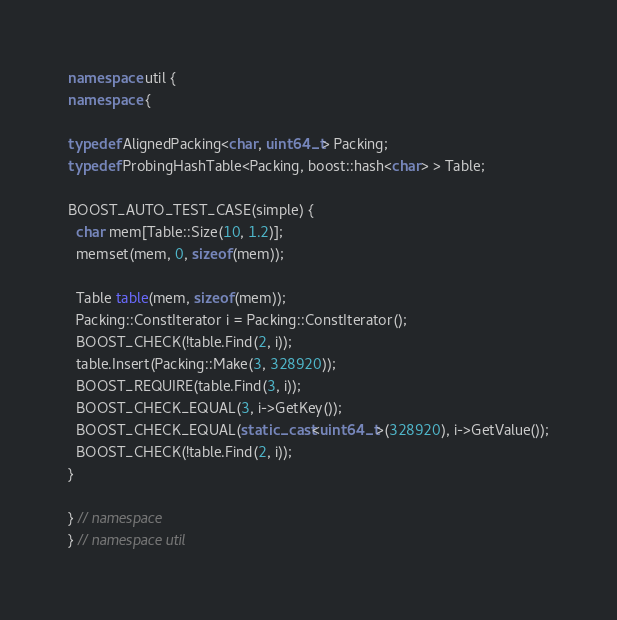<code> <loc_0><loc_0><loc_500><loc_500><_C++_>
namespace util {
namespace {

typedef AlignedPacking<char, uint64_t> Packing;
typedef ProbingHashTable<Packing, boost::hash<char> > Table;

BOOST_AUTO_TEST_CASE(simple) {
  char mem[Table::Size(10, 1.2)];
  memset(mem, 0, sizeof(mem));

  Table table(mem, sizeof(mem));
  Packing::ConstIterator i = Packing::ConstIterator();
  BOOST_CHECK(!table.Find(2, i));
  table.Insert(Packing::Make(3, 328920));
  BOOST_REQUIRE(table.Find(3, i));
  BOOST_CHECK_EQUAL(3, i->GetKey());
  BOOST_CHECK_EQUAL(static_cast<uint64_t>(328920), i->GetValue());
  BOOST_CHECK(!table.Find(2, i));
}

} // namespace
} // namespace util
</code> 